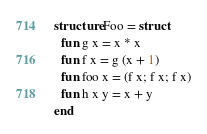<code> <loc_0><loc_0><loc_500><loc_500><_SML_>structure Foo = struct
  fun g x = x * x
  fun f x = g (x + 1)
  fun foo x = (f x; f x; f x)
  fun h x y = x + y
end
</code> 